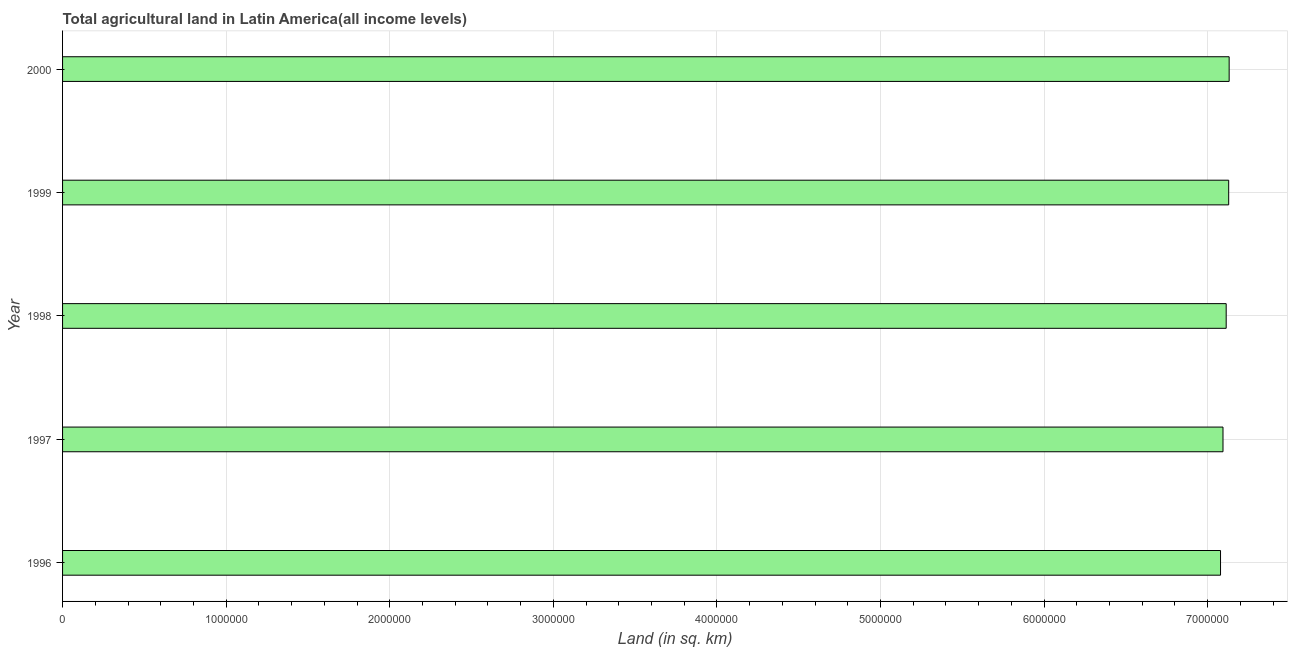Does the graph contain grids?
Your answer should be compact. Yes. What is the title of the graph?
Offer a terse response. Total agricultural land in Latin America(all income levels). What is the label or title of the X-axis?
Your answer should be very brief. Land (in sq. km). What is the label or title of the Y-axis?
Offer a terse response. Year. What is the agricultural land in 1998?
Offer a very short reply. 7.11e+06. Across all years, what is the maximum agricultural land?
Offer a terse response. 7.13e+06. Across all years, what is the minimum agricultural land?
Your answer should be compact. 7.08e+06. In which year was the agricultural land maximum?
Keep it short and to the point. 2000. What is the sum of the agricultural land?
Your answer should be compact. 3.55e+07. What is the difference between the agricultural land in 1996 and 1999?
Your answer should be compact. -4.98e+04. What is the average agricultural land per year?
Keep it short and to the point. 7.11e+06. What is the median agricultural land?
Your answer should be compact. 7.11e+06. In how many years, is the agricultural land greater than 4800000 sq. km?
Give a very brief answer. 5. Is the agricultural land in 1997 less than that in 1999?
Your answer should be compact. Yes. Is the difference between the agricultural land in 1997 and 1998 greater than the difference between any two years?
Give a very brief answer. No. What is the difference between the highest and the second highest agricultural land?
Offer a terse response. 2896. Is the sum of the agricultural land in 1998 and 1999 greater than the maximum agricultural land across all years?
Give a very brief answer. Yes. What is the difference between the highest and the lowest agricultural land?
Your response must be concise. 5.27e+04. In how many years, is the agricultural land greater than the average agricultural land taken over all years?
Your answer should be very brief. 3. How many bars are there?
Your response must be concise. 5. Are all the bars in the graph horizontal?
Offer a very short reply. Yes. How many years are there in the graph?
Your response must be concise. 5. What is the difference between two consecutive major ticks on the X-axis?
Offer a very short reply. 1.00e+06. What is the Land (in sq. km) of 1996?
Make the answer very short. 7.08e+06. What is the Land (in sq. km) in 1997?
Offer a very short reply. 7.09e+06. What is the Land (in sq. km) of 1998?
Your answer should be compact. 7.11e+06. What is the Land (in sq. km) in 1999?
Ensure brevity in your answer.  7.13e+06. What is the Land (in sq. km) of 2000?
Your answer should be very brief. 7.13e+06. What is the difference between the Land (in sq. km) in 1996 and 1997?
Your answer should be compact. -1.51e+04. What is the difference between the Land (in sq. km) in 1996 and 1998?
Offer a terse response. -3.45e+04. What is the difference between the Land (in sq. km) in 1996 and 1999?
Keep it short and to the point. -4.98e+04. What is the difference between the Land (in sq. km) in 1996 and 2000?
Your answer should be compact. -5.27e+04. What is the difference between the Land (in sq. km) in 1997 and 1998?
Make the answer very short. -1.94e+04. What is the difference between the Land (in sq. km) in 1997 and 1999?
Give a very brief answer. -3.47e+04. What is the difference between the Land (in sq. km) in 1997 and 2000?
Provide a succinct answer. -3.76e+04. What is the difference between the Land (in sq. km) in 1998 and 1999?
Make the answer very short. -1.53e+04. What is the difference between the Land (in sq. km) in 1998 and 2000?
Offer a very short reply. -1.82e+04. What is the difference between the Land (in sq. km) in 1999 and 2000?
Your response must be concise. -2896. What is the ratio of the Land (in sq. km) in 1996 to that in 2000?
Offer a very short reply. 0.99. What is the ratio of the Land (in sq. km) in 1998 to that in 1999?
Offer a terse response. 1. 